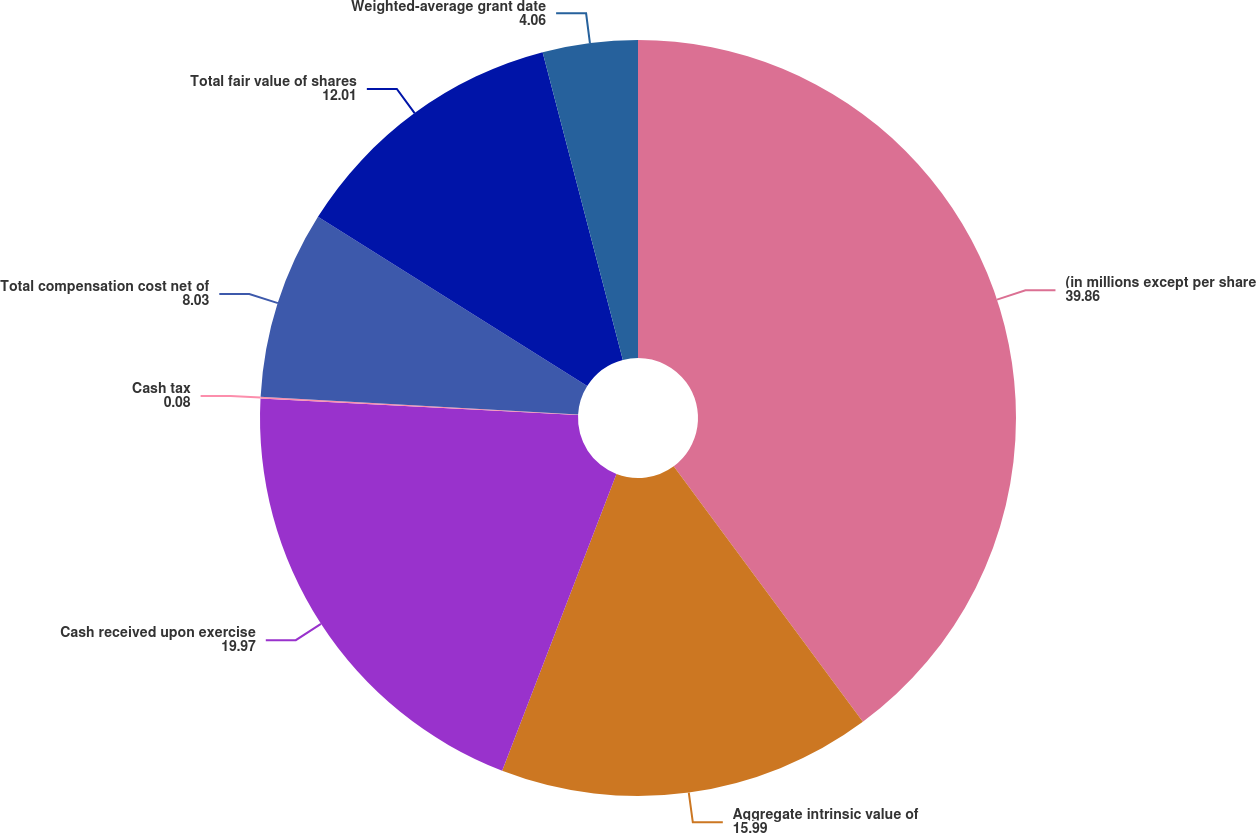Convert chart to OTSL. <chart><loc_0><loc_0><loc_500><loc_500><pie_chart><fcel>(in millions except per share<fcel>Aggregate intrinsic value of<fcel>Cash received upon exercise<fcel>Cash tax<fcel>Total compensation cost net of<fcel>Total fair value of shares<fcel>Weighted-average grant date<nl><fcel>39.86%<fcel>15.99%<fcel>19.97%<fcel>0.08%<fcel>8.03%<fcel>12.01%<fcel>4.06%<nl></chart> 